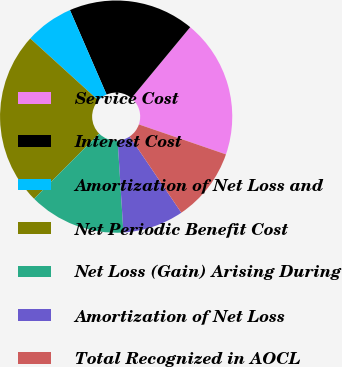Convert chart. <chart><loc_0><loc_0><loc_500><loc_500><pie_chart><fcel>Service Cost<fcel>Interest Cost<fcel>Amortization of Net Loss and<fcel>Net Periodic Benefit Cost<fcel>Net Loss (Gain) Arising During<fcel>Amortization of Net Loss<fcel>Total Recognized in AOCL<nl><fcel>19.27%<fcel>17.52%<fcel>6.74%<fcel>24.26%<fcel>13.48%<fcel>8.49%<fcel>10.24%<nl></chart> 